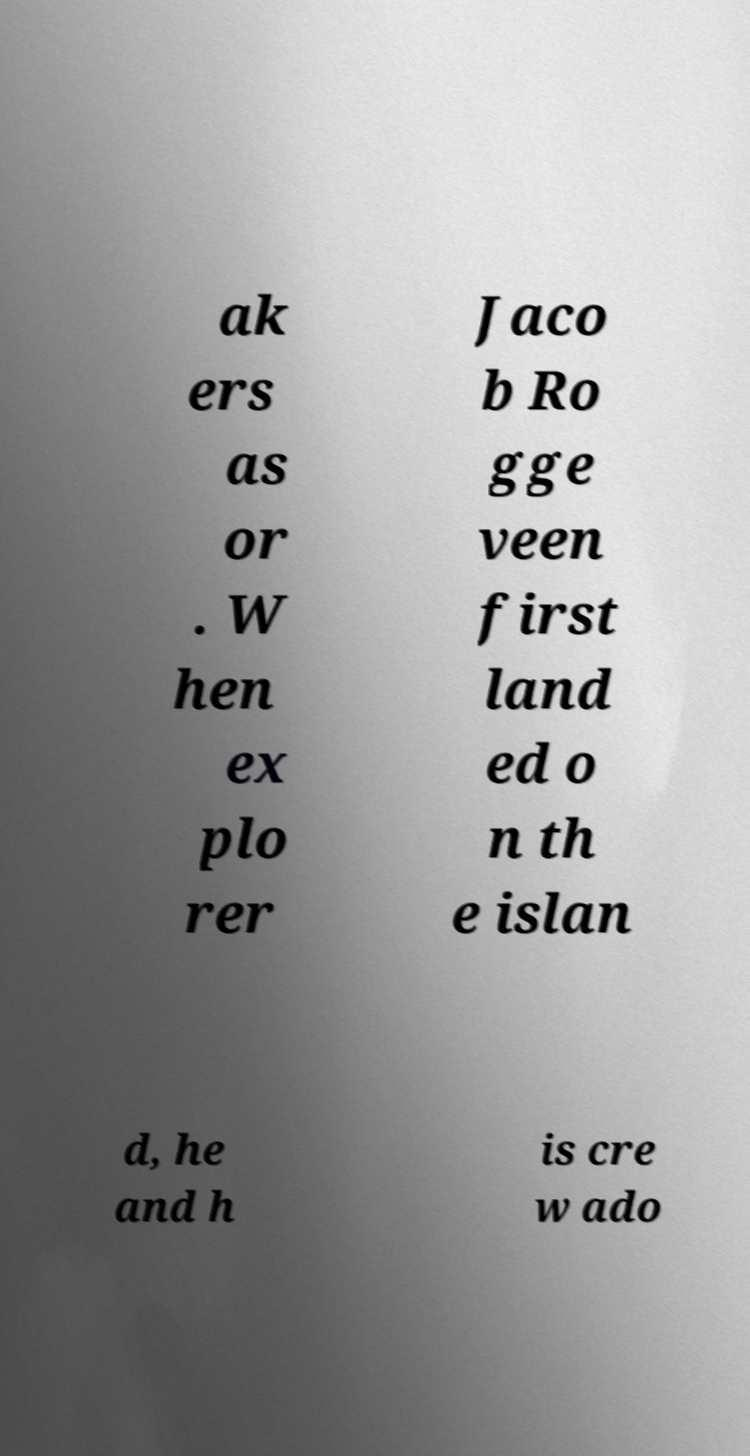Could you assist in decoding the text presented in this image and type it out clearly? ak ers as or . W hen ex plo rer Jaco b Ro gge veen first land ed o n th e islan d, he and h is cre w ado 